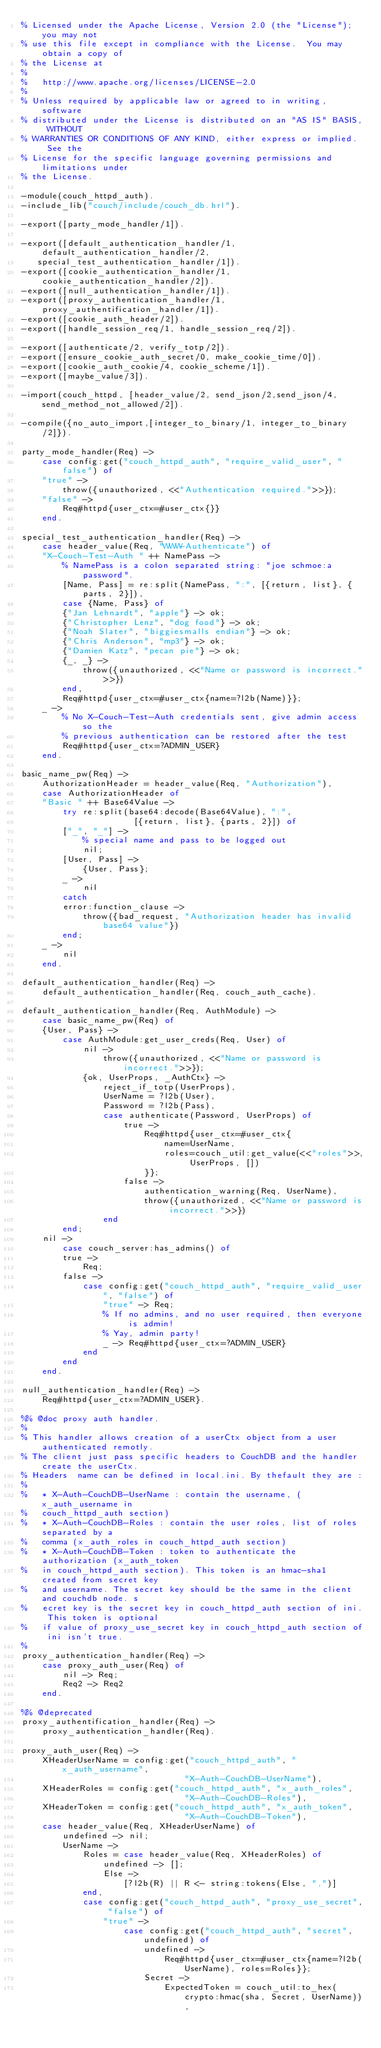<code> <loc_0><loc_0><loc_500><loc_500><_Erlang_>% Licensed under the Apache License, Version 2.0 (the "License"); you may not
% use this file except in compliance with the License.  You may obtain a copy of
% the License at
%
%   http://www.apache.org/licenses/LICENSE-2.0
%
% Unless required by applicable law or agreed to in writing, software
% distributed under the License is distributed on an "AS IS" BASIS, WITHOUT
% WARRANTIES OR CONDITIONS OF ANY KIND, either express or implied.  See the
% License for the specific language governing permissions and limitations under
% the License.

-module(couch_httpd_auth).
-include_lib("couch/include/couch_db.hrl").

-export([party_mode_handler/1]).

-export([default_authentication_handler/1, default_authentication_handler/2,
	 special_test_authentication_handler/1]).
-export([cookie_authentication_handler/1, cookie_authentication_handler/2]).
-export([null_authentication_handler/1]).
-export([proxy_authentication_handler/1, proxy_authentification_handler/1]).
-export([cookie_auth_header/2]).
-export([handle_session_req/1, handle_session_req/2]).

-export([authenticate/2, verify_totp/2]).
-export([ensure_cookie_auth_secret/0, make_cookie_time/0]).
-export([cookie_auth_cookie/4, cookie_scheme/1]).
-export([maybe_value/3]).

-import(couch_httpd, [header_value/2, send_json/2,send_json/4, send_method_not_allowed/2]).

-compile({no_auto_import,[integer_to_binary/1, integer_to_binary/2]}).

party_mode_handler(Req) ->
    case config:get("couch_httpd_auth", "require_valid_user", "false") of
    "true" ->
        throw({unauthorized, <<"Authentication required.">>});
    "false" ->
        Req#httpd{user_ctx=#user_ctx{}}
    end.

special_test_authentication_handler(Req) ->
    case header_value(Req, "WWW-Authenticate") of
    "X-Couch-Test-Auth " ++ NamePass ->
        % NamePass is a colon separated string: "joe schmoe:a password".
        [Name, Pass] = re:split(NamePass, ":", [{return, list}, {parts, 2}]),
        case {Name, Pass} of
        {"Jan Lehnardt", "apple"} -> ok;
        {"Christopher Lenz", "dog food"} -> ok;
        {"Noah Slater", "biggiesmalls endian"} -> ok;
        {"Chris Anderson", "mp3"} -> ok;
        {"Damien Katz", "pecan pie"} -> ok;
        {_, _} ->
            throw({unauthorized, <<"Name or password is incorrect.">>})
        end,
        Req#httpd{user_ctx=#user_ctx{name=?l2b(Name)}};
    _ ->
        % No X-Couch-Test-Auth credentials sent, give admin access so the
        % previous authentication can be restored after the test
        Req#httpd{user_ctx=?ADMIN_USER}
    end.

basic_name_pw(Req) ->
    AuthorizationHeader = header_value(Req, "Authorization"),
    case AuthorizationHeader of
    "Basic " ++ Base64Value ->
        try re:split(base64:decode(Base64Value), ":",
                      [{return, list}, {parts, 2}]) of
        ["_", "_"] ->
            % special name and pass to be logged out
            nil;
        [User, Pass] ->
            {User, Pass};
        _ ->
            nil
        catch
        error:function_clause ->
            throw({bad_request, "Authorization header has invalid base64 value"})
        end;
    _ ->
        nil
    end.

default_authentication_handler(Req) ->
    default_authentication_handler(Req, couch_auth_cache).

default_authentication_handler(Req, AuthModule) ->
    case basic_name_pw(Req) of
    {User, Pass} ->
        case AuthModule:get_user_creds(Req, User) of
            nil ->
                throw({unauthorized, <<"Name or password is incorrect.">>});
            {ok, UserProps, _AuthCtx} ->
                reject_if_totp(UserProps),
                UserName = ?l2b(User),
                Password = ?l2b(Pass),
                case authenticate(Password, UserProps) of
                    true ->
                        Req#httpd{user_ctx=#user_ctx{
                            name=UserName,
                            roles=couch_util:get_value(<<"roles">>, UserProps, [])
                        }};
                    false ->
                        authentication_warning(Req, UserName),
                        throw({unauthorized, <<"Name or password is incorrect.">>})
                end
        end;
    nil ->
        case couch_server:has_admins() of
        true ->
            Req;
        false ->
            case config:get("couch_httpd_auth", "require_valid_user", "false") of
                "true" -> Req;
                % If no admins, and no user required, then everyone is admin!
                % Yay, admin party!
                _ -> Req#httpd{user_ctx=?ADMIN_USER}
            end
        end
    end.

null_authentication_handler(Req) ->
    Req#httpd{user_ctx=?ADMIN_USER}.

%% @doc proxy auth handler.
%
% This handler allows creation of a userCtx object from a user authenticated remotly.
% The client just pass specific headers to CouchDB and the handler create the userCtx.
% Headers  name can be defined in local.ini. By thefault they are :
%
%   * X-Auth-CouchDB-UserName : contain the username, (x_auth_username in
%   couch_httpd_auth section)
%   * X-Auth-CouchDB-Roles : contain the user roles, list of roles separated by a
%   comma (x_auth_roles in couch_httpd_auth section)
%   * X-Auth-CouchDB-Token : token to authenticate the authorization (x_auth_token
%   in couch_httpd_auth section). This token is an hmac-sha1 created from secret key
%   and username. The secret key should be the same in the client and couchdb node. s
%   ecret key is the secret key in couch_httpd_auth section of ini. This token is optional
%   if value of proxy_use_secret key in couch_httpd_auth section of ini isn't true.
%
proxy_authentication_handler(Req) ->
    case proxy_auth_user(Req) of
        nil -> Req;
        Req2 -> Req2
    end.

%% @deprecated
proxy_authentification_handler(Req) ->
    proxy_authentication_handler(Req).
    
proxy_auth_user(Req) ->
    XHeaderUserName = config:get("couch_httpd_auth", "x_auth_username",
                                "X-Auth-CouchDB-UserName"),
    XHeaderRoles = config:get("couch_httpd_auth", "x_auth_roles",
                                "X-Auth-CouchDB-Roles"),
    XHeaderToken = config:get("couch_httpd_auth", "x_auth_token",
                                "X-Auth-CouchDB-Token"),
    case header_value(Req, XHeaderUserName) of
        undefined -> nil;
        UserName ->
            Roles = case header_value(Req, XHeaderRoles) of
                undefined -> [];
                Else ->
                    [?l2b(R) || R <- string:tokens(Else, ",")]
            end,
            case config:get("couch_httpd_auth", "proxy_use_secret", "false") of
                "true" ->
                    case config:get("couch_httpd_auth", "secret", undefined) of
                        undefined ->
                            Req#httpd{user_ctx=#user_ctx{name=?l2b(UserName), roles=Roles}};
                        Secret ->
                            ExpectedToken = couch_util:to_hex(crypto:hmac(sha, Secret, UserName)),</code> 